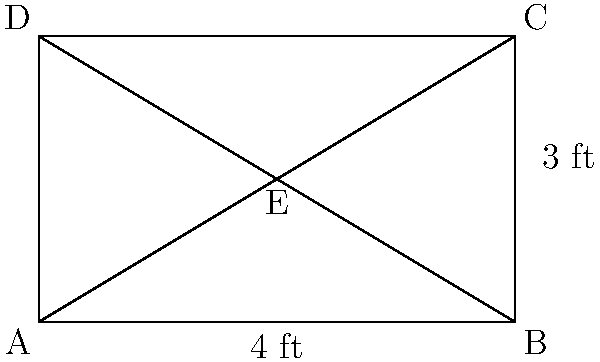You're planning to design a unique Hollywood Walk of Fame star for your latest blockbuster film. The star will be shaped like a rectangle with diagonals, creating four triangles. If the star measures 4 feet wide and 3 feet tall, and point E is where the diagonals intersect, what is the area of triangle AEB in square feet? Let's approach this step-by-step:

1) First, we need to recognize that triangle AEB is a right triangle. This is because:
   - AB is the base of the rectangle
   - AE is half of a diagonal of the rectangle
   - Diagonals of a rectangle bisect each other at right angles

2) We know the width of the rectangle (AB) is 4 feet, so the base of our triangle (AE) is 2 feet.

3) To find the height of the triangle (BE), we can use the Pythagorean theorem on the larger right triangle ABC:

   $AC^2 = AB^2 + BC^2$
   $AC^2 = 4^2 + 3^2 = 16 + 9 = 25$
   $AC = 5$ feet

4) Since E is the midpoint of AC, BE is half of BC:

   $BE = \frac{1}{2} BC = \frac{1}{2} \cdot 3 = 1.5$ feet

5) Now we have the base and height of triangle AEB. We can calculate its area using the formula:

   $Area = \frac{1}{2} \cdot base \cdot height$
   $Area = \frac{1}{2} \cdot 2 \cdot 1.5 = 1.5$ square feet

Therefore, the area of triangle AEB is 1.5 square feet.
Answer: 1.5 sq ft 